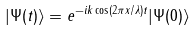<formula> <loc_0><loc_0><loc_500><loc_500>| \Psi ( t ) \rangle = e ^ { - i k \cos ( 2 \pi x / \lambda ) t } | \Psi ( 0 ) \rangle</formula> 